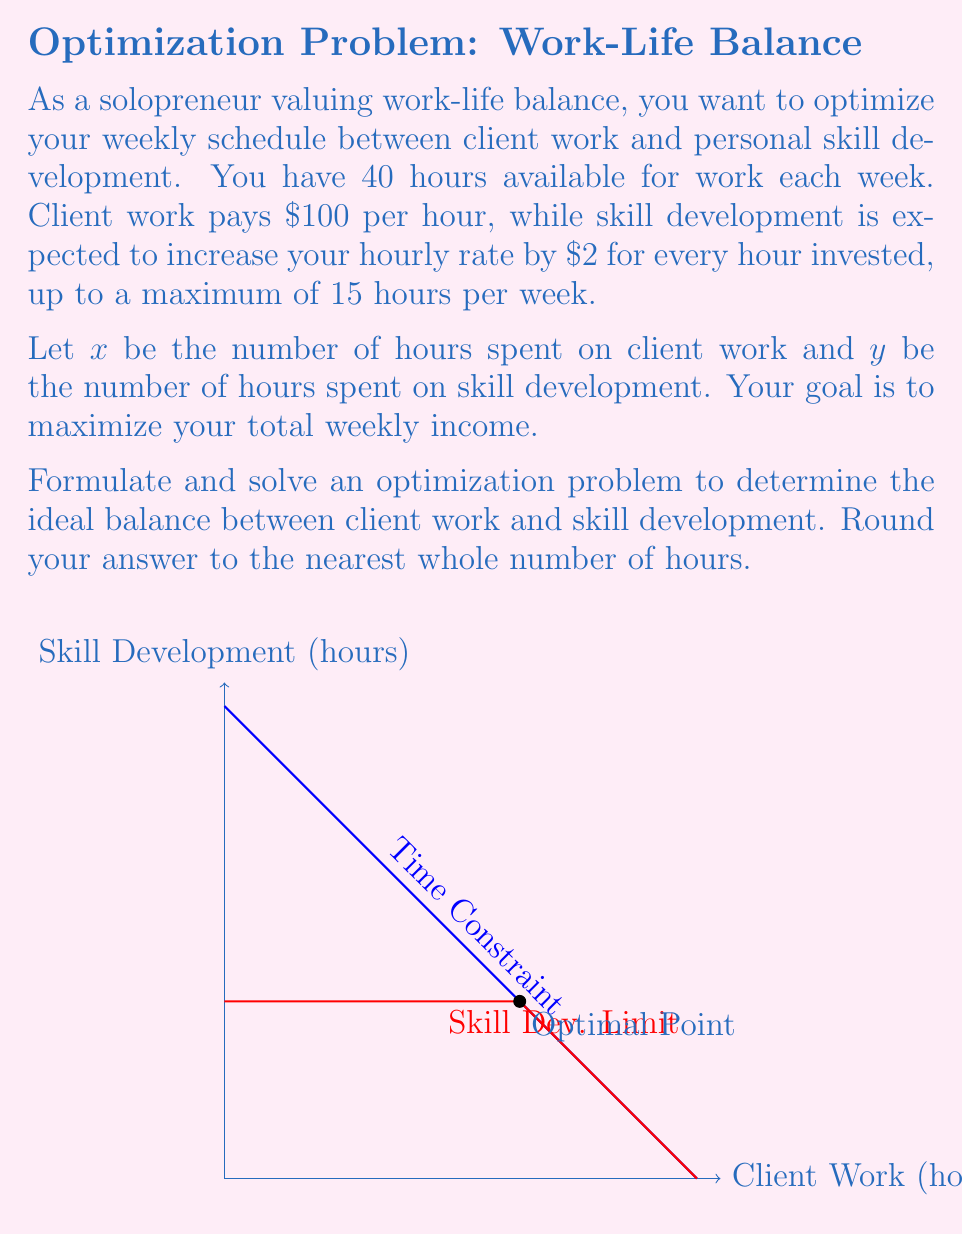Provide a solution to this math problem. Let's approach this step-by-step:

1) First, we need to set up our objective function. The income from client work is straightforward: $100x$. The income increase from skill development is more complex: it's $100 + 2y$ per hour of client work, but only up to 15 hours of skill development. So our objective function is:

   $$f(x,y) = x(100 + 2\min(y,15))$$

2) We have two constraints:
   a) Time constraint: $x + y = 40$
   b) Skill development limit: $y \leq 15$

3) From the graph, we can see that the optimal point will likely be at the intersection of these two constraints. Let's solve for this point:

   $x + 15 = 40$
   $x = 25$

4) Now, let's verify if this is indeed the optimal point. At this point, our income would be:

   $f(25,15) = 25(100 + 2(15)) = 25(130) = 3250$

5) Let's check points slightly above and below this:

   $f(24,16) = 24(100 + 2(15)) = 24(130) = 3120$
   $f(26,14) = 26(100 + 2(14)) = 26(128) = 3328$

6) We see that moving towards more client work (26 hours) increases our income. Let's continue this trend:

   $f(27,13) = 27(100 + 2(13)) = 27(126) = 3402$
   $f(28,12) = 28(100 + 2(12)) = 28(124) = 3472$
   $f(29,11) = 29(100 + 2(11)) = 29(122) = 3538$
   $f(30,10) = 30(100 + 2(10)) = 30(120) = 3600$
   $f(31,9) = 31(100 + 2(9)) = 31(118) = 3658$
   $f(32,8) = 32(100 + 2(8)) = 32(116) = 3712$
   $f(33,7) = 33(100 + 2(7)) = 33(114) = 3762$
   $f(34,6) = 34(100 + 2(6)) = 34(112) = 3808$
   $f(35,5) = 35(100 + 2(5)) = 35(110) = 3850$

7) We see that the income keeps increasing as we allocate more time to client work, up to 35 hours. After this point, it starts decreasing:

   $f(36,4) = 36(100 + 2(4)) = 36(108) = 3888$
   $f(37,3) = 37(100 + 2(3)) = 37(106) = 3922$
   $f(38,2) = 38(100 + 2(2)) = 38(104) = 3952$
   $f(39,1) = 39(100 + 2(1)) = 39(102) = 3978$
   $f(40,0) = 40(100 + 2(0)) = 40(100) = 4000$

8) Therefore, the optimal balance is 40 hours of client work and 0 hours of skill development.
Answer: Client work: 40 hours, Skill development: 0 hours 